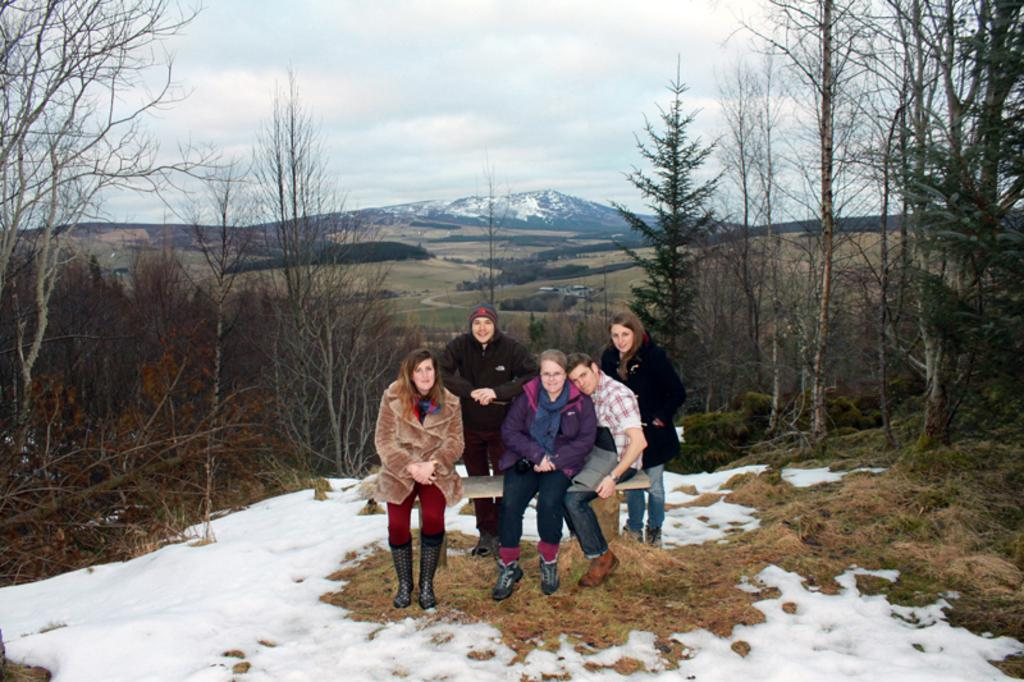What are the people in the image doing? There are people seated and standing in the image. What type of vegetation is present in the image? There are trees in the image. What is the terrain like in the image? There is a hill in the image. What is the ground covered with in the image? There is snow and grass on the ground in the image. What is the weather like in the image? The sky is cloudy in the image. What type of account is being discussed by the people in the image? There is no indication in the image that the people are discussing any type of account. 